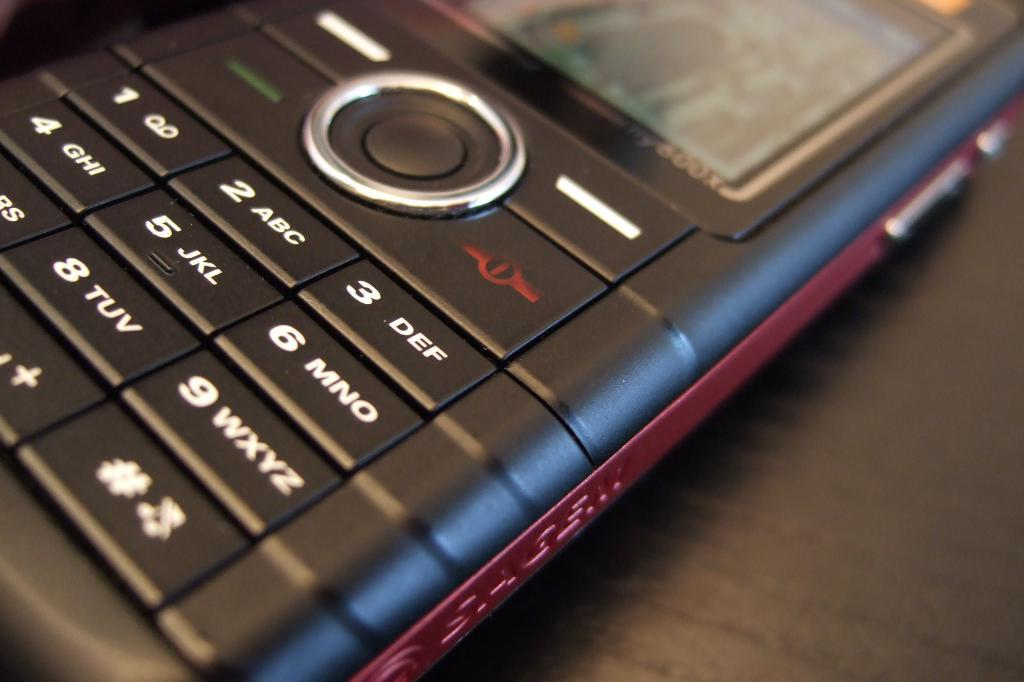<image>
Share a concise interpretation of the image provided. A keypad cellphone with red trim and the word 600x below the edge of the screen 